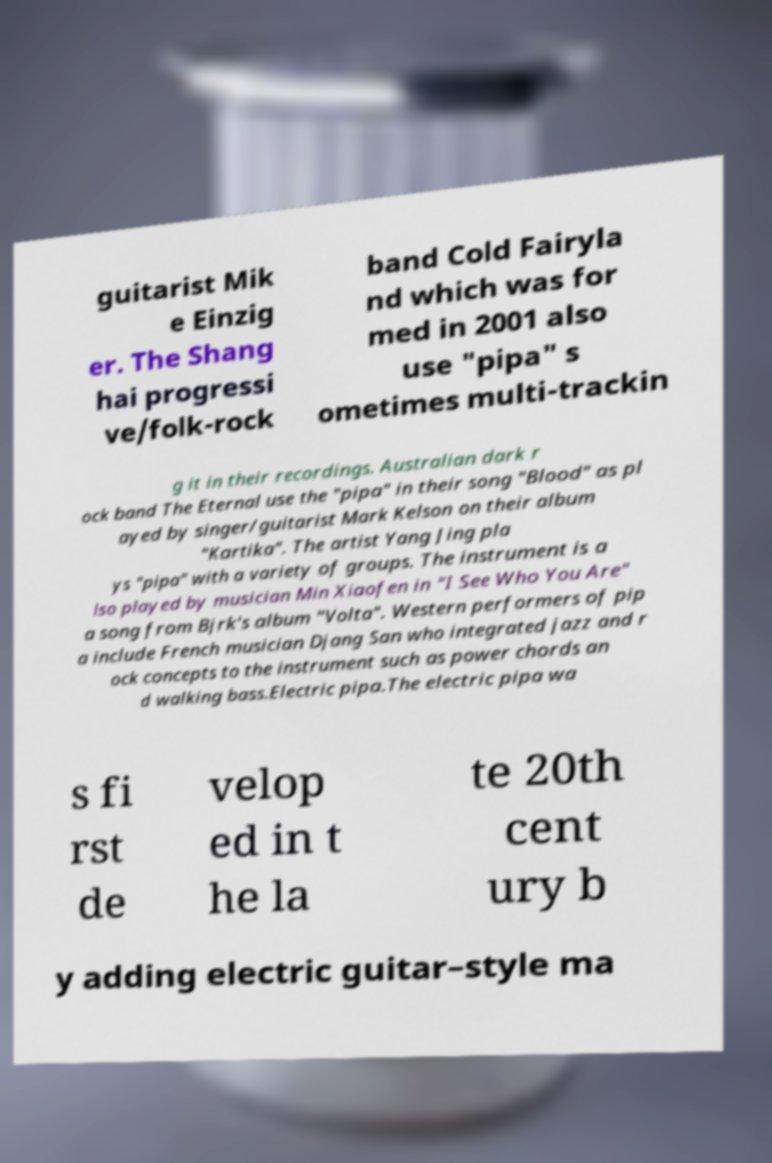Please identify and transcribe the text found in this image. guitarist Mik e Einzig er. The Shang hai progressi ve/folk-rock band Cold Fairyla nd which was for med in 2001 also use "pipa" s ometimes multi-trackin g it in their recordings. Australian dark r ock band The Eternal use the "pipa" in their song "Blood" as pl ayed by singer/guitarist Mark Kelson on their album "Kartika". The artist Yang Jing pla ys "pipa" with a variety of groups. The instrument is a lso played by musician Min Xiaofen in "I See Who You Are" a song from Bjrk's album "Volta". Western performers of pip a include French musician Djang San who integrated jazz and r ock concepts to the instrument such as power chords an d walking bass.Electric pipa.The electric pipa wa s fi rst de velop ed in t he la te 20th cent ury b y adding electric guitar–style ma 